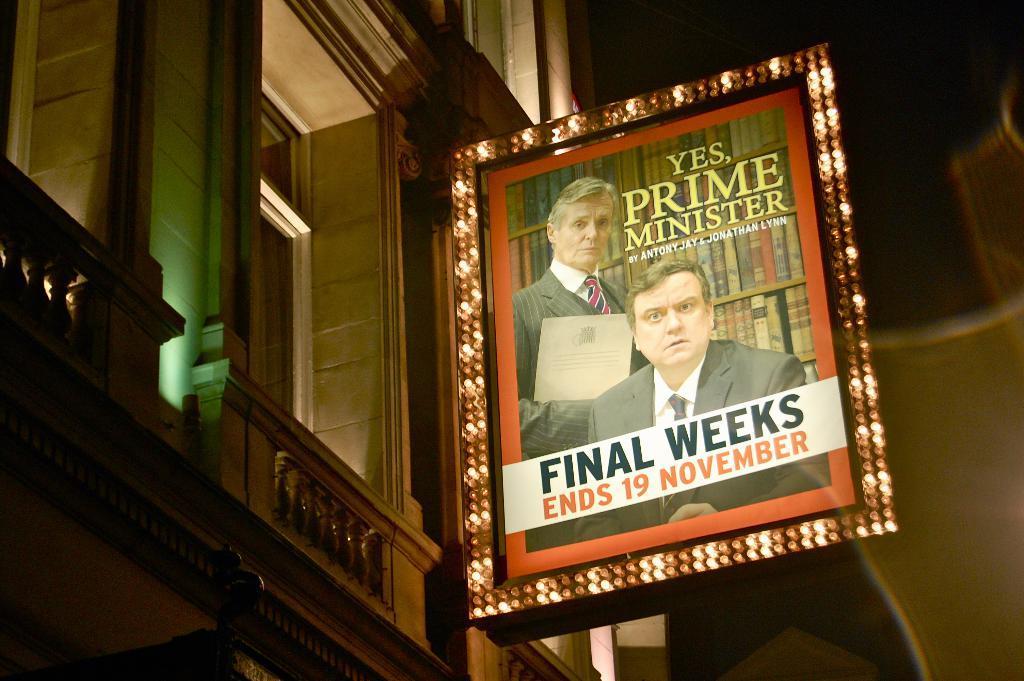Describe this image in one or two sentences. In this image there is a building truncated towards the left of the image, there is a board, there is text on the board, there are lights on the board, there are two persons on the board, one of them is holding an object, there are books, the background of the image is dark. 